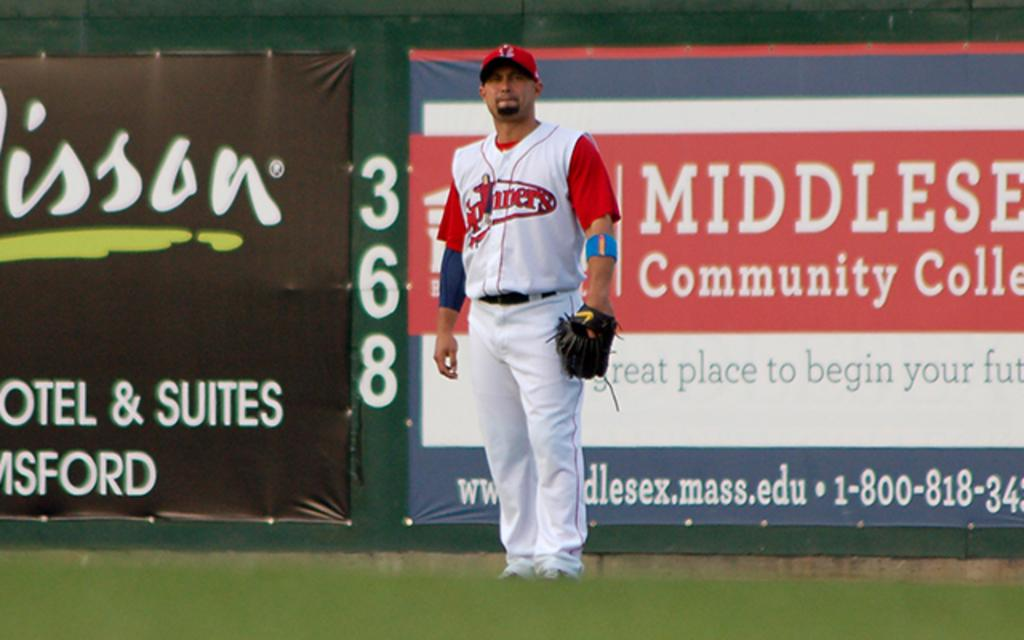<image>
Relay a brief, clear account of the picture shown. A baseball player standing infront of a community college banner 